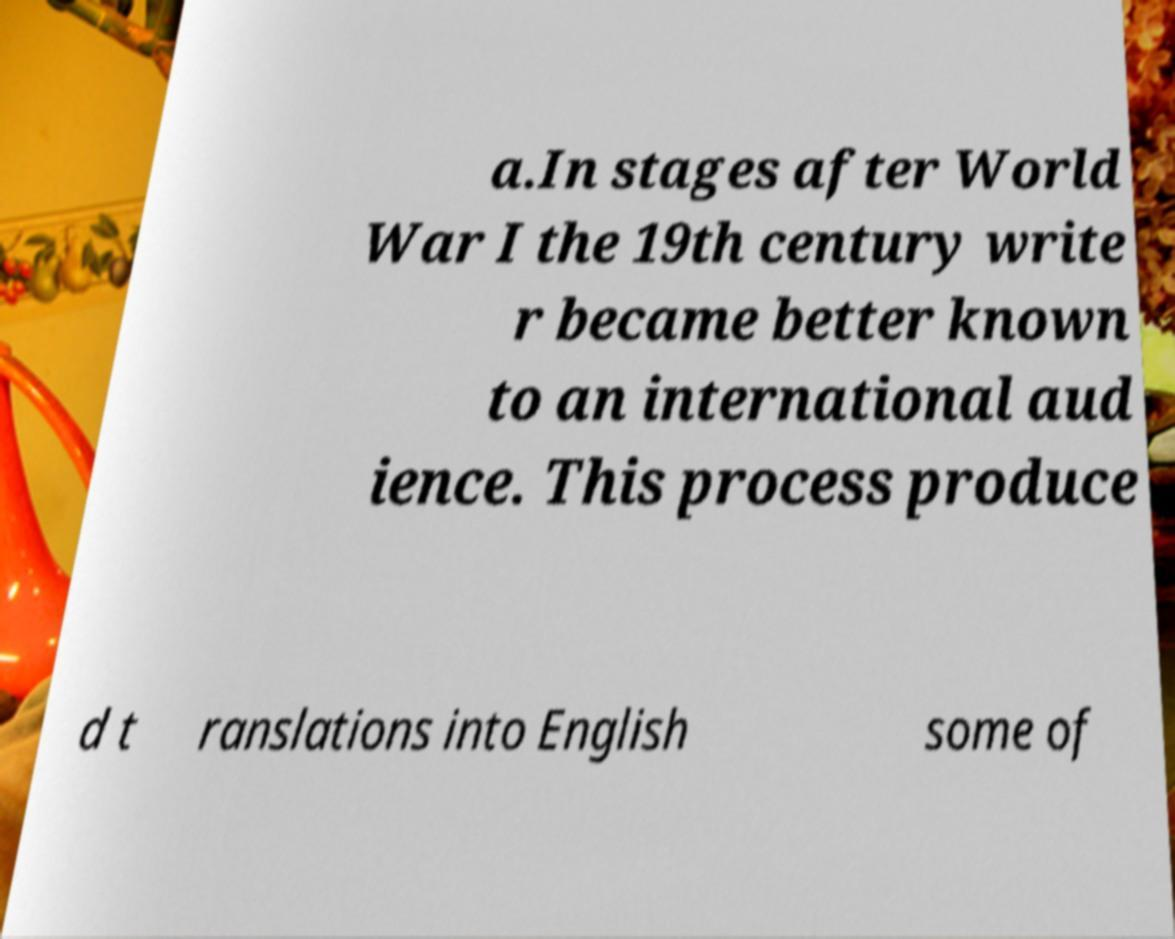For documentation purposes, I need the text within this image transcribed. Could you provide that? a.In stages after World War I the 19th century write r became better known to an international aud ience. This process produce d t ranslations into English some of 